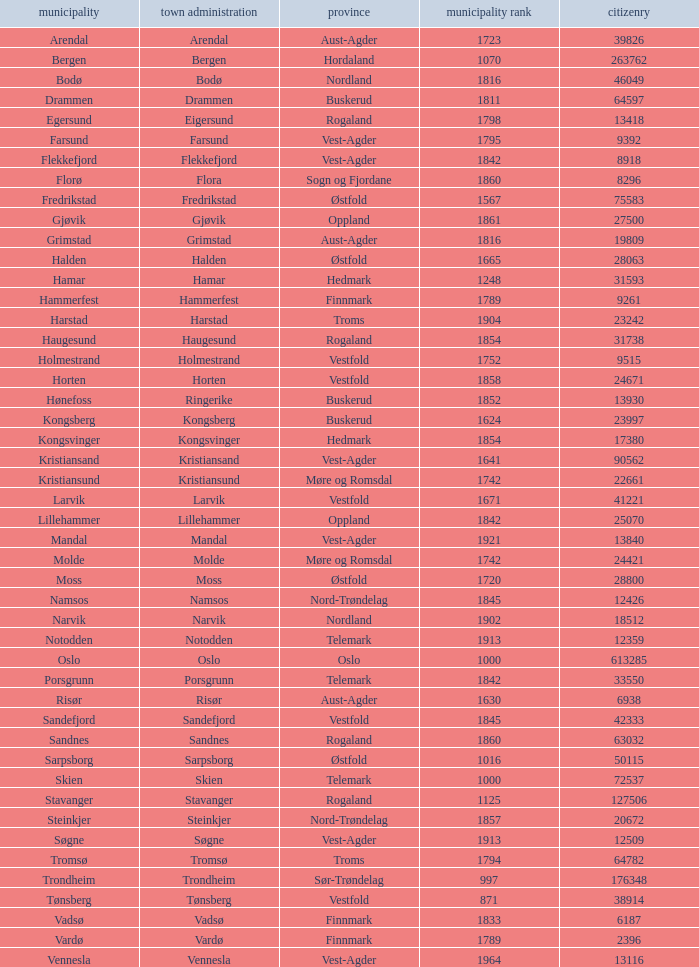Which municipality has a population of 24421? Molde. 